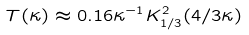Convert formula to latex. <formula><loc_0><loc_0><loc_500><loc_500>T ( \kappa ) \approx 0 . 1 6 \kappa ^ { - 1 } K ^ { 2 } _ { 1 / 3 } ( 4 / 3 \kappa )</formula> 